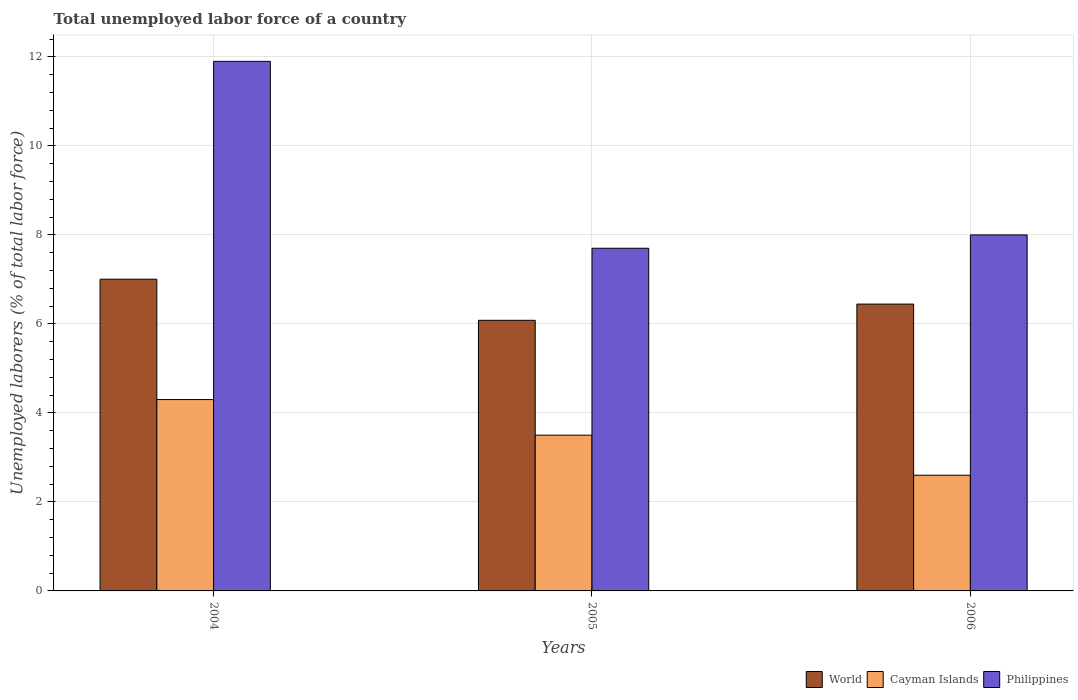Are the number of bars per tick equal to the number of legend labels?
Your answer should be very brief. Yes. What is the total unemployed labor force in Philippines in 2005?
Your answer should be very brief. 7.7. Across all years, what is the maximum total unemployed labor force in Cayman Islands?
Offer a very short reply. 4.3. Across all years, what is the minimum total unemployed labor force in Cayman Islands?
Provide a succinct answer. 2.6. In which year was the total unemployed labor force in Philippines maximum?
Your answer should be compact. 2004. What is the total total unemployed labor force in Cayman Islands in the graph?
Keep it short and to the point. 10.4. What is the difference between the total unemployed labor force in Cayman Islands in 2004 and that in 2005?
Keep it short and to the point. 0.8. What is the difference between the total unemployed labor force in World in 2006 and the total unemployed labor force in Cayman Islands in 2004?
Make the answer very short. 2.15. What is the average total unemployed labor force in Cayman Islands per year?
Make the answer very short. 3.47. In the year 2006, what is the difference between the total unemployed labor force in World and total unemployed labor force in Philippines?
Provide a succinct answer. -1.55. What is the ratio of the total unemployed labor force in Philippines in 2005 to that in 2006?
Your response must be concise. 0.96. Is the difference between the total unemployed labor force in World in 2004 and 2005 greater than the difference between the total unemployed labor force in Philippines in 2004 and 2005?
Your answer should be very brief. No. What is the difference between the highest and the second highest total unemployed labor force in Philippines?
Offer a terse response. 3.9. What is the difference between the highest and the lowest total unemployed labor force in World?
Provide a short and direct response. 0.92. What does the 1st bar from the left in 2006 represents?
Give a very brief answer. World. How many bars are there?
Your answer should be compact. 9. Are all the bars in the graph horizontal?
Offer a very short reply. No. How many years are there in the graph?
Provide a succinct answer. 3. Are the values on the major ticks of Y-axis written in scientific E-notation?
Ensure brevity in your answer.  No. Does the graph contain grids?
Offer a terse response. Yes. How many legend labels are there?
Your answer should be very brief. 3. How are the legend labels stacked?
Offer a very short reply. Horizontal. What is the title of the graph?
Provide a short and direct response. Total unemployed labor force of a country. What is the label or title of the X-axis?
Provide a short and direct response. Years. What is the label or title of the Y-axis?
Ensure brevity in your answer.  Unemployed laborers (% of total labor force). What is the Unemployed laborers (% of total labor force) in World in 2004?
Keep it short and to the point. 7.01. What is the Unemployed laborers (% of total labor force) in Cayman Islands in 2004?
Make the answer very short. 4.3. What is the Unemployed laborers (% of total labor force) of Philippines in 2004?
Provide a succinct answer. 11.9. What is the Unemployed laborers (% of total labor force) in World in 2005?
Provide a short and direct response. 6.08. What is the Unemployed laborers (% of total labor force) in Cayman Islands in 2005?
Your answer should be compact. 3.5. What is the Unemployed laborers (% of total labor force) of Philippines in 2005?
Offer a very short reply. 7.7. What is the Unemployed laborers (% of total labor force) in World in 2006?
Your answer should be compact. 6.45. What is the Unemployed laborers (% of total labor force) in Cayman Islands in 2006?
Your response must be concise. 2.6. What is the Unemployed laborers (% of total labor force) in Philippines in 2006?
Provide a short and direct response. 8. Across all years, what is the maximum Unemployed laborers (% of total labor force) in World?
Offer a terse response. 7.01. Across all years, what is the maximum Unemployed laborers (% of total labor force) of Cayman Islands?
Your answer should be compact. 4.3. Across all years, what is the maximum Unemployed laborers (% of total labor force) in Philippines?
Give a very brief answer. 11.9. Across all years, what is the minimum Unemployed laborers (% of total labor force) in World?
Keep it short and to the point. 6.08. Across all years, what is the minimum Unemployed laborers (% of total labor force) of Cayman Islands?
Your answer should be very brief. 2.6. Across all years, what is the minimum Unemployed laborers (% of total labor force) in Philippines?
Your answer should be compact. 7.7. What is the total Unemployed laborers (% of total labor force) of World in the graph?
Provide a short and direct response. 19.53. What is the total Unemployed laborers (% of total labor force) in Cayman Islands in the graph?
Offer a very short reply. 10.4. What is the total Unemployed laborers (% of total labor force) in Philippines in the graph?
Provide a succinct answer. 27.6. What is the difference between the Unemployed laborers (% of total labor force) of World in 2004 and that in 2005?
Ensure brevity in your answer.  0.92. What is the difference between the Unemployed laborers (% of total labor force) in Philippines in 2004 and that in 2005?
Your answer should be compact. 4.2. What is the difference between the Unemployed laborers (% of total labor force) in World in 2004 and that in 2006?
Provide a succinct answer. 0.56. What is the difference between the Unemployed laborers (% of total labor force) in Cayman Islands in 2004 and that in 2006?
Your response must be concise. 1.7. What is the difference between the Unemployed laborers (% of total labor force) of World in 2005 and that in 2006?
Provide a succinct answer. -0.36. What is the difference between the Unemployed laborers (% of total labor force) in Cayman Islands in 2005 and that in 2006?
Give a very brief answer. 0.9. What is the difference between the Unemployed laborers (% of total labor force) of World in 2004 and the Unemployed laborers (% of total labor force) of Cayman Islands in 2005?
Your response must be concise. 3.5. What is the difference between the Unemployed laborers (% of total labor force) of World in 2004 and the Unemployed laborers (% of total labor force) of Philippines in 2005?
Offer a terse response. -0.69. What is the difference between the Unemployed laborers (% of total labor force) in Cayman Islands in 2004 and the Unemployed laborers (% of total labor force) in Philippines in 2005?
Keep it short and to the point. -3.4. What is the difference between the Unemployed laborers (% of total labor force) of World in 2004 and the Unemployed laborers (% of total labor force) of Cayman Islands in 2006?
Your response must be concise. 4.41. What is the difference between the Unemployed laborers (% of total labor force) in World in 2004 and the Unemployed laborers (% of total labor force) in Philippines in 2006?
Your response must be concise. -0.99. What is the difference between the Unemployed laborers (% of total labor force) of World in 2005 and the Unemployed laborers (% of total labor force) of Cayman Islands in 2006?
Your answer should be compact. 3.48. What is the difference between the Unemployed laborers (% of total labor force) of World in 2005 and the Unemployed laborers (% of total labor force) of Philippines in 2006?
Your response must be concise. -1.92. What is the average Unemployed laborers (% of total labor force) of World per year?
Provide a succinct answer. 6.51. What is the average Unemployed laborers (% of total labor force) in Cayman Islands per year?
Offer a very short reply. 3.47. In the year 2004, what is the difference between the Unemployed laborers (% of total labor force) in World and Unemployed laborers (% of total labor force) in Cayman Islands?
Offer a very short reply. 2.71. In the year 2004, what is the difference between the Unemployed laborers (% of total labor force) in World and Unemployed laborers (% of total labor force) in Philippines?
Your answer should be compact. -4.89. In the year 2004, what is the difference between the Unemployed laborers (% of total labor force) in Cayman Islands and Unemployed laborers (% of total labor force) in Philippines?
Provide a short and direct response. -7.6. In the year 2005, what is the difference between the Unemployed laborers (% of total labor force) in World and Unemployed laborers (% of total labor force) in Cayman Islands?
Make the answer very short. 2.58. In the year 2005, what is the difference between the Unemployed laborers (% of total labor force) of World and Unemployed laborers (% of total labor force) of Philippines?
Your response must be concise. -1.62. In the year 2006, what is the difference between the Unemployed laborers (% of total labor force) in World and Unemployed laborers (% of total labor force) in Cayman Islands?
Provide a succinct answer. 3.85. In the year 2006, what is the difference between the Unemployed laborers (% of total labor force) in World and Unemployed laborers (% of total labor force) in Philippines?
Provide a succinct answer. -1.55. In the year 2006, what is the difference between the Unemployed laborers (% of total labor force) of Cayman Islands and Unemployed laborers (% of total labor force) of Philippines?
Offer a very short reply. -5.4. What is the ratio of the Unemployed laborers (% of total labor force) of World in 2004 to that in 2005?
Ensure brevity in your answer.  1.15. What is the ratio of the Unemployed laborers (% of total labor force) of Cayman Islands in 2004 to that in 2005?
Offer a very short reply. 1.23. What is the ratio of the Unemployed laborers (% of total labor force) of Philippines in 2004 to that in 2005?
Your response must be concise. 1.55. What is the ratio of the Unemployed laborers (% of total labor force) of World in 2004 to that in 2006?
Offer a very short reply. 1.09. What is the ratio of the Unemployed laborers (% of total labor force) in Cayman Islands in 2004 to that in 2006?
Make the answer very short. 1.65. What is the ratio of the Unemployed laborers (% of total labor force) of Philippines in 2004 to that in 2006?
Provide a short and direct response. 1.49. What is the ratio of the Unemployed laborers (% of total labor force) in World in 2005 to that in 2006?
Offer a very short reply. 0.94. What is the ratio of the Unemployed laborers (% of total labor force) in Cayman Islands in 2005 to that in 2006?
Your response must be concise. 1.35. What is the ratio of the Unemployed laborers (% of total labor force) in Philippines in 2005 to that in 2006?
Your answer should be very brief. 0.96. What is the difference between the highest and the second highest Unemployed laborers (% of total labor force) of World?
Provide a succinct answer. 0.56. What is the difference between the highest and the second highest Unemployed laborers (% of total labor force) of Cayman Islands?
Your answer should be very brief. 0.8. What is the difference between the highest and the second highest Unemployed laborers (% of total labor force) in Philippines?
Give a very brief answer. 3.9. What is the difference between the highest and the lowest Unemployed laborers (% of total labor force) of World?
Make the answer very short. 0.92. What is the difference between the highest and the lowest Unemployed laborers (% of total labor force) in Philippines?
Your answer should be very brief. 4.2. 